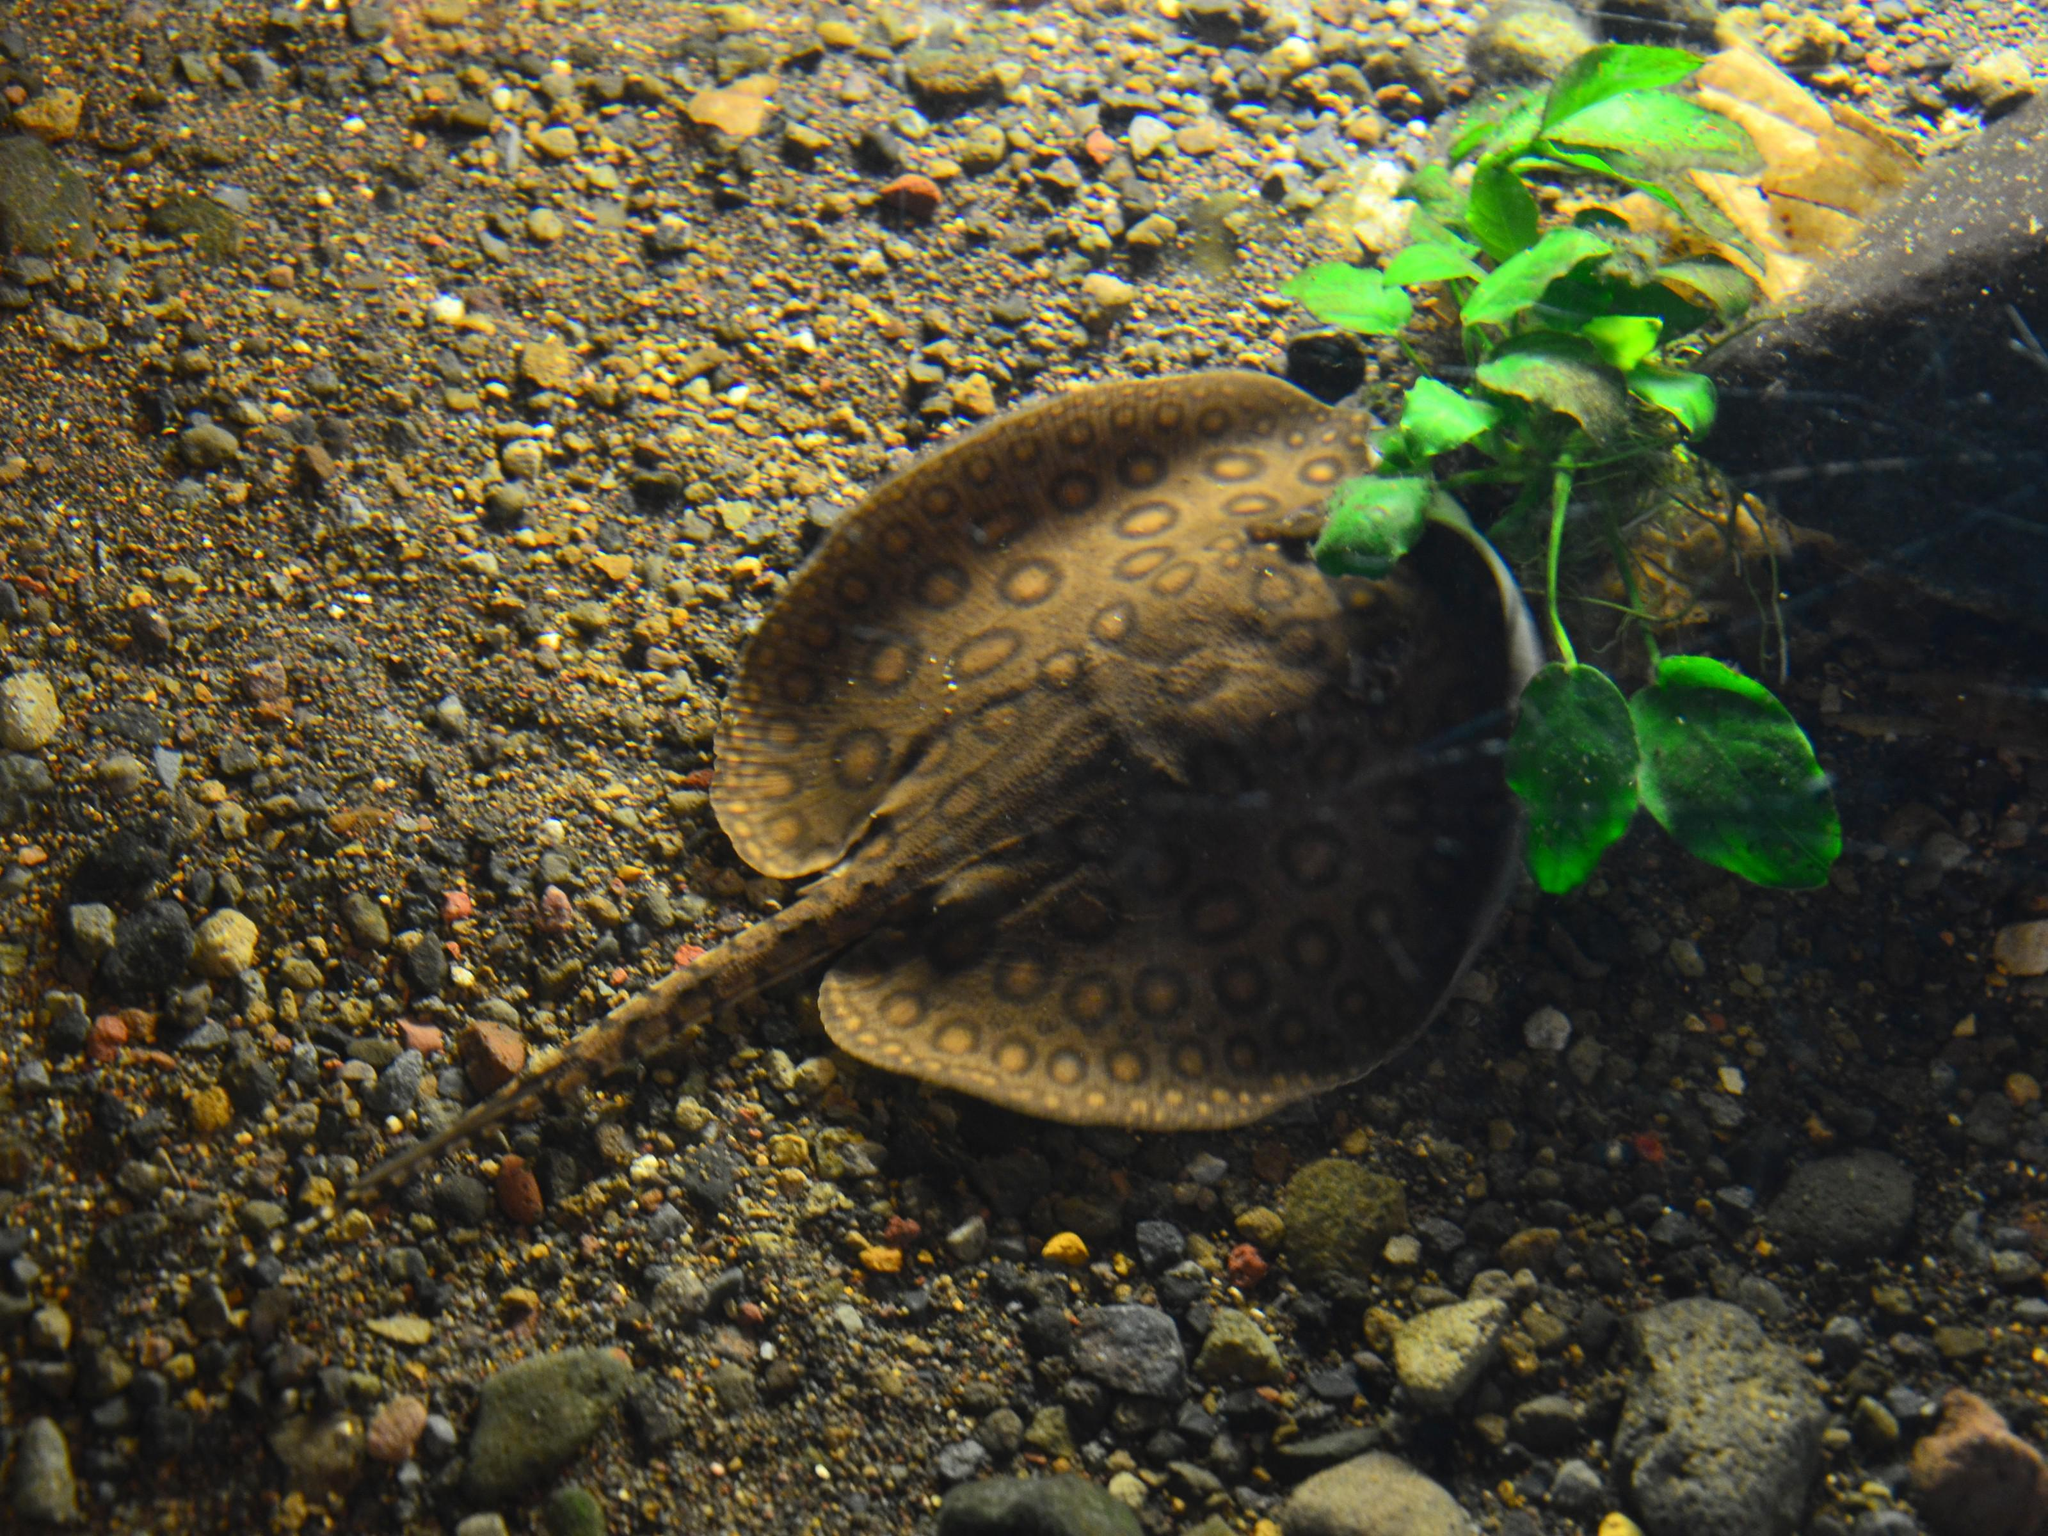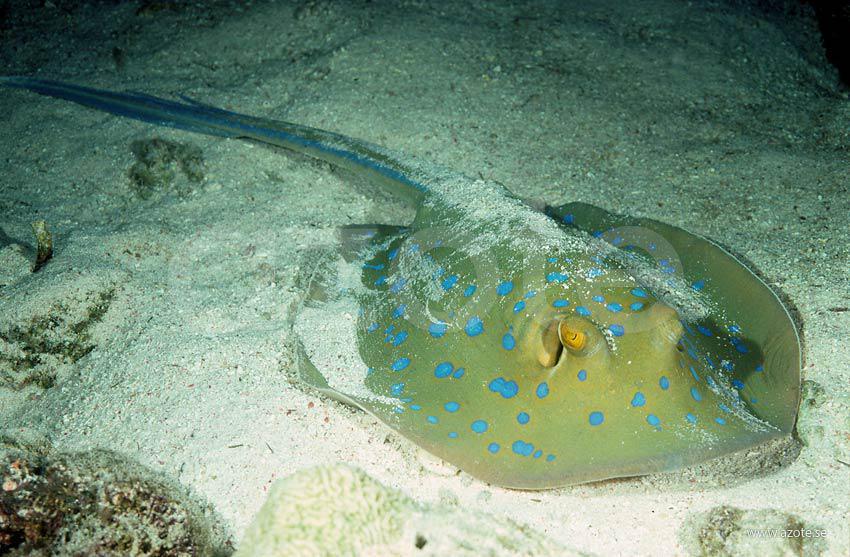The first image is the image on the left, the second image is the image on the right. Given the left and right images, does the statement "One of the rays is green and yellow with blue specks." hold true? Answer yes or no. Yes. The first image is the image on the left, the second image is the image on the right. Evaluate the accuracy of this statement regarding the images: "An image features exactly one stingray, which has sky-blue dots.". Is it true? Answer yes or no. Yes. 